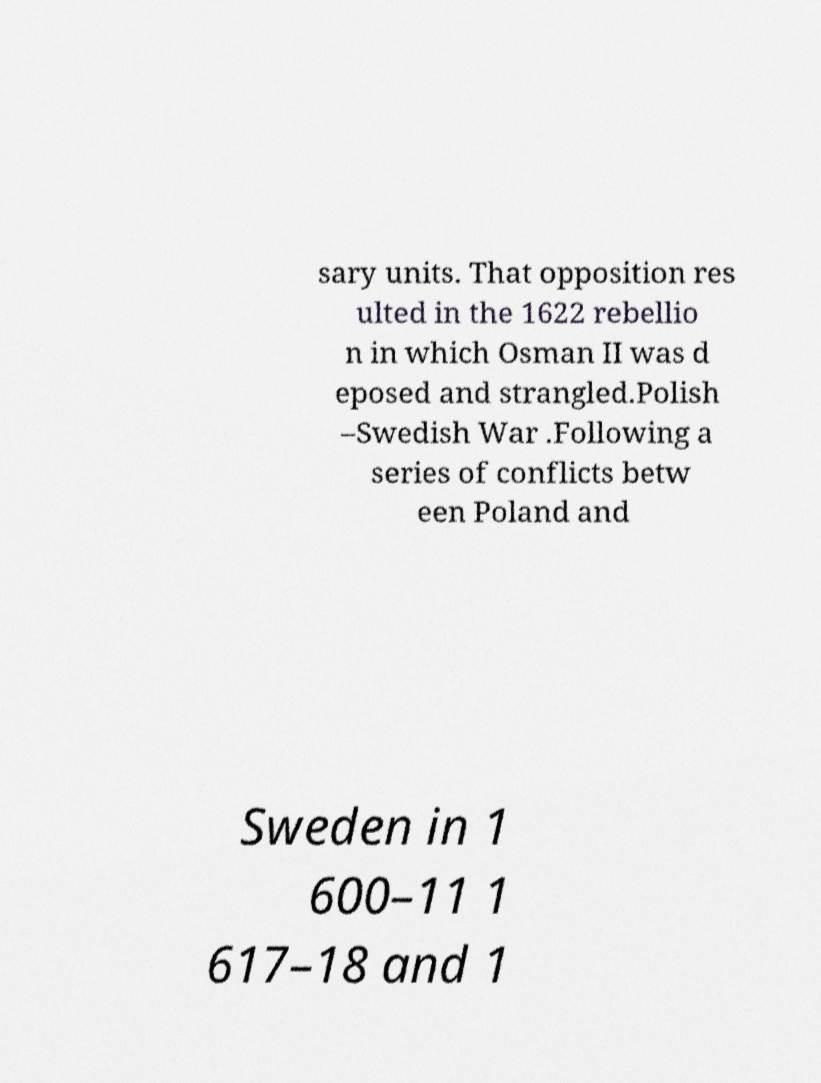I need the written content from this picture converted into text. Can you do that? sary units. That opposition res ulted in the 1622 rebellio n in which Osman II was d eposed and strangled.Polish –Swedish War .Following a series of conflicts betw een Poland and Sweden in 1 600–11 1 617–18 and 1 